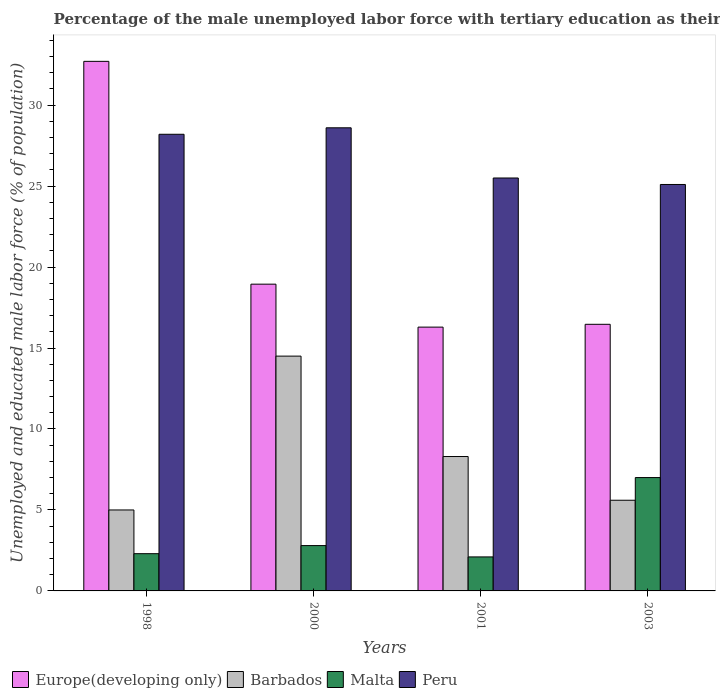Are the number of bars on each tick of the X-axis equal?
Make the answer very short. Yes. How many bars are there on the 2nd tick from the right?
Your response must be concise. 4. Across all years, what is the maximum percentage of the unemployed male labor force with tertiary education in Barbados?
Your answer should be compact. 14.5. In which year was the percentage of the unemployed male labor force with tertiary education in Malta minimum?
Offer a very short reply. 2001. What is the total percentage of the unemployed male labor force with tertiary education in Barbados in the graph?
Give a very brief answer. 33.4. What is the difference between the percentage of the unemployed male labor force with tertiary education in Peru in 2000 and that in 2001?
Keep it short and to the point. 3.1. What is the difference between the percentage of the unemployed male labor force with tertiary education in Malta in 2000 and the percentage of the unemployed male labor force with tertiary education in Europe(developing only) in 2003?
Provide a succinct answer. -13.66. What is the average percentage of the unemployed male labor force with tertiary education in Barbados per year?
Ensure brevity in your answer.  8.35. In the year 1998, what is the difference between the percentage of the unemployed male labor force with tertiary education in Peru and percentage of the unemployed male labor force with tertiary education in Europe(developing only)?
Make the answer very short. -4.5. In how many years, is the percentage of the unemployed male labor force with tertiary education in Europe(developing only) greater than 21 %?
Keep it short and to the point. 1. What is the ratio of the percentage of the unemployed male labor force with tertiary education in Europe(developing only) in 1998 to that in 2000?
Your answer should be very brief. 1.73. What is the difference between the highest and the second highest percentage of the unemployed male labor force with tertiary education in Europe(developing only)?
Make the answer very short. 13.76. What is the difference between the highest and the lowest percentage of the unemployed male labor force with tertiary education in Malta?
Make the answer very short. 4.9. In how many years, is the percentage of the unemployed male labor force with tertiary education in Europe(developing only) greater than the average percentage of the unemployed male labor force with tertiary education in Europe(developing only) taken over all years?
Your response must be concise. 1. Is the sum of the percentage of the unemployed male labor force with tertiary education in Europe(developing only) in 1998 and 2001 greater than the maximum percentage of the unemployed male labor force with tertiary education in Barbados across all years?
Keep it short and to the point. Yes. What does the 2nd bar from the left in 2003 represents?
Provide a succinct answer. Barbados. What does the 2nd bar from the right in 1998 represents?
Make the answer very short. Malta. Are all the bars in the graph horizontal?
Offer a terse response. No. What is the difference between two consecutive major ticks on the Y-axis?
Your response must be concise. 5. Are the values on the major ticks of Y-axis written in scientific E-notation?
Give a very brief answer. No. Does the graph contain any zero values?
Give a very brief answer. No. Does the graph contain grids?
Your response must be concise. No. Where does the legend appear in the graph?
Keep it short and to the point. Bottom left. How many legend labels are there?
Make the answer very short. 4. How are the legend labels stacked?
Offer a terse response. Horizontal. What is the title of the graph?
Keep it short and to the point. Percentage of the male unemployed labor force with tertiary education as their highest grade. What is the label or title of the X-axis?
Offer a terse response. Years. What is the label or title of the Y-axis?
Make the answer very short. Unemployed and educated male labor force (% of population). What is the Unemployed and educated male labor force (% of population) in Europe(developing only) in 1998?
Keep it short and to the point. 32.7. What is the Unemployed and educated male labor force (% of population) of Malta in 1998?
Your answer should be very brief. 2.3. What is the Unemployed and educated male labor force (% of population) of Peru in 1998?
Your response must be concise. 28.2. What is the Unemployed and educated male labor force (% of population) of Europe(developing only) in 2000?
Your answer should be very brief. 18.94. What is the Unemployed and educated male labor force (% of population) of Malta in 2000?
Provide a succinct answer. 2.8. What is the Unemployed and educated male labor force (% of population) of Peru in 2000?
Offer a very short reply. 28.6. What is the Unemployed and educated male labor force (% of population) in Europe(developing only) in 2001?
Ensure brevity in your answer.  16.29. What is the Unemployed and educated male labor force (% of population) in Barbados in 2001?
Make the answer very short. 8.3. What is the Unemployed and educated male labor force (% of population) of Malta in 2001?
Give a very brief answer. 2.1. What is the Unemployed and educated male labor force (% of population) in Europe(developing only) in 2003?
Ensure brevity in your answer.  16.46. What is the Unemployed and educated male labor force (% of population) in Barbados in 2003?
Keep it short and to the point. 5.6. What is the Unemployed and educated male labor force (% of population) of Peru in 2003?
Provide a short and direct response. 25.1. Across all years, what is the maximum Unemployed and educated male labor force (% of population) of Europe(developing only)?
Give a very brief answer. 32.7. Across all years, what is the maximum Unemployed and educated male labor force (% of population) of Peru?
Provide a succinct answer. 28.6. Across all years, what is the minimum Unemployed and educated male labor force (% of population) in Europe(developing only)?
Your answer should be very brief. 16.29. Across all years, what is the minimum Unemployed and educated male labor force (% of population) in Malta?
Give a very brief answer. 2.1. Across all years, what is the minimum Unemployed and educated male labor force (% of population) in Peru?
Provide a succinct answer. 25.1. What is the total Unemployed and educated male labor force (% of population) of Europe(developing only) in the graph?
Your answer should be compact. 84.4. What is the total Unemployed and educated male labor force (% of population) of Barbados in the graph?
Give a very brief answer. 33.4. What is the total Unemployed and educated male labor force (% of population) of Peru in the graph?
Offer a very short reply. 107.4. What is the difference between the Unemployed and educated male labor force (% of population) of Europe(developing only) in 1998 and that in 2000?
Your answer should be compact. 13.76. What is the difference between the Unemployed and educated male labor force (% of population) of Barbados in 1998 and that in 2000?
Give a very brief answer. -9.5. What is the difference between the Unemployed and educated male labor force (% of population) of Europe(developing only) in 1998 and that in 2001?
Offer a terse response. 16.41. What is the difference between the Unemployed and educated male labor force (% of population) in Barbados in 1998 and that in 2001?
Provide a short and direct response. -3.3. What is the difference between the Unemployed and educated male labor force (% of population) of Europe(developing only) in 1998 and that in 2003?
Ensure brevity in your answer.  16.24. What is the difference between the Unemployed and educated male labor force (% of population) of Malta in 1998 and that in 2003?
Provide a short and direct response. -4.7. What is the difference between the Unemployed and educated male labor force (% of population) in Peru in 1998 and that in 2003?
Your response must be concise. 3.1. What is the difference between the Unemployed and educated male labor force (% of population) in Europe(developing only) in 2000 and that in 2001?
Your answer should be very brief. 2.65. What is the difference between the Unemployed and educated male labor force (% of population) in Malta in 2000 and that in 2001?
Your response must be concise. 0.7. What is the difference between the Unemployed and educated male labor force (% of population) of Europe(developing only) in 2000 and that in 2003?
Give a very brief answer. 2.48. What is the difference between the Unemployed and educated male labor force (% of population) of Barbados in 2000 and that in 2003?
Offer a terse response. 8.9. What is the difference between the Unemployed and educated male labor force (% of population) in Malta in 2000 and that in 2003?
Your response must be concise. -4.2. What is the difference between the Unemployed and educated male labor force (% of population) of Europe(developing only) in 2001 and that in 2003?
Provide a short and direct response. -0.17. What is the difference between the Unemployed and educated male labor force (% of population) of Barbados in 2001 and that in 2003?
Provide a short and direct response. 2.7. What is the difference between the Unemployed and educated male labor force (% of population) in Malta in 2001 and that in 2003?
Your answer should be compact. -4.9. What is the difference between the Unemployed and educated male labor force (% of population) in Europe(developing only) in 1998 and the Unemployed and educated male labor force (% of population) in Barbados in 2000?
Provide a short and direct response. 18.2. What is the difference between the Unemployed and educated male labor force (% of population) of Europe(developing only) in 1998 and the Unemployed and educated male labor force (% of population) of Malta in 2000?
Make the answer very short. 29.9. What is the difference between the Unemployed and educated male labor force (% of population) of Europe(developing only) in 1998 and the Unemployed and educated male labor force (% of population) of Peru in 2000?
Make the answer very short. 4.1. What is the difference between the Unemployed and educated male labor force (% of population) of Barbados in 1998 and the Unemployed and educated male labor force (% of population) of Peru in 2000?
Make the answer very short. -23.6. What is the difference between the Unemployed and educated male labor force (% of population) of Malta in 1998 and the Unemployed and educated male labor force (% of population) of Peru in 2000?
Your answer should be very brief. -26.3. What is the difference between the Unemployed and educated male labor force (% of population) of Europe(developing only) in 1998 and the Unemployed and educated male labor force (% of population) of Barbados in 2001?
Your answer should be very brief. 24.4. What is the difference between the Unemployed and educated male labor force (% of population) in Europe(developing only) in 1998 and the Unemployed and educated male labor force (% of population) in Malta in 2001?
Your answer should be very brief. 30.6. What is the difference between the Unemployed and educated male labor force (% of population) of Europe(developing only) in 1998 and the Unemployed and educated male labor force (% of population) of Peru in 2001?
Ensure brevity in your answer.  7.2. What is the difference between the Unemployed and educated male labor force (% of population) of Barbados in 1998 and the Unemployed and educated male labor force (% of population) of Peru in 2001?
Your answer should be compact. -20.5. What is the difference between the Unemployed and educated male labor force (% of population) in Malta in 1998 and the Unemployed and educated male labor force (% of population) in Peru in 2001?
Your response must be concise. -23.2. What is the difference between the Unemployed and educated male labor force (% of population) in Europe(developing only) in 1998 and the Unemployed and educated male labor force (% of population) in Barbados in 2003?
Offer a terse response. 27.1. What is the difference between the Unemployed and educated male labor force (% of population) in Europe(developing only) in 1998 and the Unemployed and educated male labor force (% of population) in Malta in 2003?
Your answer should be very brief. 25.7. What is the difference between the Unemployed and educated male labor force (% of population) in Europe(developing only) in 1998 and the Unemployed and educated male labor force (% of population) in Peru in 2003?
Offer a very short reply. 7.6. What is the difference between the Unemployed and educated male labor force (% of population) in Barbados in 1998 and the Unemployed and educated male labor force (% of population) in Peru in 2003?
Your answer should be compact. -20.1. What is the difference between the Unemployed and educated male labor force (% of population) in Malta in 1998 and the Unemployed and educated male labor force (% of population) in Peru in 2003?
Keep it short and to the point. -22.8. What is the difference between the Unemployed and educated male labor force (% of population) in Europe(developing only) in 2000 and the Unemployed and educated male labor force (% of population) in Barbados in 2001?
Provide a short and direct response. 10.64. What is the difference between the Unemployed and educated male labor force (% of population) in Europe(developing only) in 2000 and the Unemployed and educated male labor force (% of population) in Malta in 2001?
Offer a very short reply. 16.84. What is the difference between the Unemployed and educated male labor force (% of population) in Europe(developing only) in 2000 and the Unemployed and educated male labor force (% of population) in Peru in 2001?
Your answer should be very brief. -6.56. What is the difference between the Unemployed and educated male labor force (% of population) in Barbados in 2000 and the Unemployed and educated male labor force (% of population) in Malta in 2001?
Your answer should be very brief. 12.4. What is the difference between the Unemployed and educated male labor force (% of population) of Barbados in 2000 and the Unemployed and educated male labor force (% of population) of Peru in 2001?
Keep it short and to the point. -11. What is the difference between the Unemployed and educated male labor force (% of population) of Malta in 2000 and the Unemployed and educated male labor force (% of population) of Peru in 2001?
Make the answer very short. -22.7. What is the difference between the Unemployed and educated male labor force (% of population) in Europe(developing only) in 2000 and the Unemployed and educated male labor force (% of population) in Barbados in 2003?
Give a very brief answer. 13.34. What is the difference between the Unemployed and educated male labor force (% of population) of Europe(developing only) in 2000 and the Unemployed and educated male labor force (% of population) of Malta in 2003?
Offer a very short reply. 11.94. What is the difference between the Unemployed and educated male labor force (% of population) of Europe(developing only) in 2000 and the Unemployed and educated male labor force (% of population) of Peru in 2003?
Your answer should be compact. -6.16. What is the difference between the Unemployed and educated male labor force (% of population) in Malta in 2000 and the Unemployed and educated male labor force (% of population) in Peru in 2003?
Offer a very short reply. -22.3. What is the difference between the Unemployed and educated male labor force (% of population) in Europe(developing only) in 2001 and the Unemployed and educated male labor force (% of population) in Barbados in 2003?
Ensure brevity in your answer.  10.69. What is the difference between the Unemployed and educated male labor force (% of population) of Europe(developing only) in 2001 and the Unemployed and educated male labor force (% of population) of Malta in 2003?
Offer a terse response. 9.29. What is the difference between the Unemployed and educated male labor force (% of population) of Europe(developing only) in 2001 and the Unemployed and educated male labor force (% of population) of Peru in 2003?
Provide a succinct answer. -8.81. What is the difference between the Unemployed and educated male labor force (% of population) of Barbados in 2001 and the Unemployed and educated male labor force (% of population) of Peru in 2003?
Your answer should be very brief. -16.8. What is the average Unemployed and educated male labor force (% of population) of Europe(developing only) per year?
Keep it short and to the point. 21.1. What is the average Unemployed and educated male labor force (% of population) in Barbados per year?
Make the answer very short. 8.35. What is the average Unemployed and educated male labor force (% of population) in Malta per year?
Your response must be concise. 3.55. What is the average Unemployed and educated male labor force (% of population) of Peru per year?
Make the answer very short. 26.85. In the year 1998, what is the difference between the Unemployed and educated male labor force (% of population) in Europe(developing only) and Unemployed and educated male labor force (% of population) in Barbados?
Ensure brevity in your answer.  27.7. In the year 1998, what is the difference between the Unemployed and educated male labor force (% of population) of Europe(developing only) and Unemployed and educated male labor force (% of population) of Malta?
Your answer should be very brief. 30.4. In the year 1998, what is the difference between the Unemployed and educated male labor force (% of population) of Europe(developing only) and Unemployed and educated male labor force (% of population) of Peru?
Ensure brevity in your answer.  4.5. In the year 1998, what is the difference between the Unemployed and educated male labor force (% of population) in Barbados and Unemployed and educated male labor force (% of population) in Peru?
Provide a short and direct response. -23.2. In the year 1998, what is the difference between the Unemployed and educated male labor force (% of population) of Malta and Unemployed and educated male labor force (% of population) of Peru?
Keep it short and to the point. -25.9. In the year 2000, what is the difference between the Unemployed and educated male labor force (% of population) in Europe(developing only) and Unemployed and educated male labor force (% of population) in Barbados?
Ensure brevity in your answer.  4.44. In the year 2000, what is the difference between the Unemployed and educated male labor force (% of population) of Europe(developing only) and Unemployed and educated male labor force (% of population) of Malta?
Your answer should be very brief. 16.14. In the year 2000, what is the difference between the Unemployed and educated male labor force (% of population) in Europe(developing only) and Unemployed and educated male labor force (% of population) in Peru?
Keep it short and to the point. -9.66. In the year 2000, what is the difference between the Unemployed and educated male labor force (% of population) of Barbados and Unemployed and educated male labor force (% of population) of Peru?
Your response must be concise. -14.1. In the year 2000, what is the difference between the Unemployed and educated male labor force (% of population) in Malta and Unemployed and educated male labor force (% of population) in Peru?
Offer a very short reply. -25.8. In the year 2001, what is the difference between the Unemployed and educated male labor force (% of population) in Europe(developing only) and Unemployed and educated male labor force (% of population) in Barbados?
Make the answer very short. 7.99. In the year 2001, what is the difference between the Unemployed and educated male labor force (% of population) in Europe(developing only) and Unemployed and educated male labor force (% of population) in Malta?
Your answer should be compact. 14.19. In the year 2001, what is the difference between the Unemployed and educated male labor force (% of population) of Europe(developing only) and Unemployed and educated male labor force (% of population) of Peru?
Provide a succinct answer. -9.21. In the year 2001, what is the difference between the Unemployed and educated male labor force (% of population) in Barbados and Unemployed and educated male labor force (% of population) in Peru?
Offer a terse response. -17.2. In the year 2001, what is the difference between the Unemployed and educated male labor force (% of population) in Malta and Unemployed and educated male labor force (% of population) in Peru?
Give a very brief answer. -23.4. In the year 2003, what is the difference between the Unemployed and educated male labor force (% of population) of Europe(developing only) and Unemployed and educated male labor force (% of population) of Barbados?
Your answer should be very brief. 10.86. In the year 2003, what is the difference between the Unemployed and educated male labor force (% of population) in Europe(developing only) and Unemployed and educated male labor force (% of population) in Malta?
Offer a terse response. 9.46. In the year 2003, what is the difference between the Unemployed and educated male labor force (% of population) in Europe(developing only) and Unemployed and educated male labor force (% of population) in Peru?
Your answer should be compact. -8.64. In the year 2003, what is the difference between the Unemployed and educated male labor force (% of population) of Barbados and Unemployed and educated male labor force (% of population) of Malta?
Your answer should be very brief. -1.4. In the year 2003, what is the difference between the Unemployed and educated male labor force (% of population) of Barbados and Unemployed and educated male labor force (% of population) of Peru?
Keep it short and to the point. -19.5. In the year 2003, what is the difference between the Unemployed and educated male labor force (% of population) in Malta and Unemployed and educated male labor force (% of population) in Peru?
Ensure brevity in your answer.  -18.1. What is the ratio of the Unemployed and educated male labor force (% of population) of Europe(developing only) in 1998 to that in 2000?
Ensure brevity in your answer.  1.73. What is the ratio of the Unemployed and educated male labor force (% of population) in Barbados in 1998 to that in 2000?
Give a very brief answer. 0.34. What is the ratio of the Unemployed and educated male labor force (% of population) in Malta in 1998 to that in 2000?
Keep it short and to the point. 0.82. What is the ratio of the Unemployed and educated male labor force (% of population) of Peru in 1998 to that in 2000?
Give a very brief answer. 0.99. What is the ratio of the Unemployed and educated male labor force (% of population) in Europe(developing only) in 1998 to that in 2001?
Give a very brief answer. 2.01. What is the ratio of the Unemployed and educated male labor force (% of population) of Barbados in 1998 to that in 2001?
Offer a very short reply. 0.6. What is the ratio of the Unemployed and educated male labor force (% of population) of Malta in 1998 to that in 2001?
Your answer should be very brief. 1.1. What is the ratio of the Unemployed and educated male labor force (% of population) of Peru in 1998 to that in 2001?
Provide a short and direct response. 1.11. What is the ratio of the Unemployed and educated male labor force (% of population) of Europe(developing only) in 1998 to that in 2003?
Give a very brief answer. 1.99. What is the ratio of the Unemployed and educated male labor force (% of population) of Barbados in 1998 to that in 2003?
Give a very brief answer. 0.89. What is the ratio of the Unemployed and educated male labor force (% of population) of Malta in 1998 to that in 2003?
Give a very brief answer. 0.33. What is the ratio of the Unemployed and educated male labor force (% of population) in Peru in 1998 to that in 2003?
Make the answer very short. 1.12. What is the ratio of the Unemployed and educated male labor force (% of population) of Europe(developing only) in 2000 to that in 2001?
Provide a succinct answer. 1.16. What is the ratio of the Unemployed and educated male labor force (% of population) in Barbados in 2000 to that in 2001?
Your response must be concise. 1.75. What is the ratio of the Unemployed and educated male labor force (% of population) in Malta in 2000 to that in 2001?
Give a very brief answer. 1.33. What is the ratio of the Unemployed and educated male labor force (% of population) in Peru in 2000 to that in 2001?
Keep it short and to the point. 1.12. What is the ratio of the Unemployed and educated male labor force (% of population) in Europe(developing only) in 2000 to that in 2003?
Provide a succinct answer. 1.15. What is the ratio of the Unemployed and educated male labor force (% of population) in Barbados in 2000 to that in 2003?
Give a very brief answer. 2.59. What is the ratio of the Unemployed and educated male labor force (% of population) in Malta in 2000 to that in 2003?
Keep it short and to the point. 0.4. What is the ratio of the Unemployed and educated male labor force (% of population) in Peru in 2000 to that in 2003?
Offer a terse response. 1.14. What is the ratio of the Unemployed and educated male labor force (% of population) in Europe(developing only) in 2001 to that in 2003?
Ensure brevity in your answer.  0.99. What is the ratio of the Unemployed and educated male labor force (% of population) in Barbados in 2001 to that in 2003?
Make the answer very short. 1.48. What is the ratio of the Unemployed and educated male labor force (% of population) of Malta in 2001 to that in 2003?
Give a very brief answer. 0.3. What is the ratio of the Unemployed and educated male labor force (% of population) in Peru in 2001 to that in 2003?
Ensure brevity in your answer.  1.02. What is the difference between the highest and the second highest Unemployed and educated male labor force (% of population) in Europe(developing only)?
Keep it short and to the point. 13.76. What is the difference between the highest and the second highest Unemployed and educated male labor force (% of population) of Barbados?
Keep it short and to the point. 6.2. What is the difference between the highest and the second highest Unemployed and educated male labor force (% of population) of Malta?
Offer a very short reply. 4.2. What is the difference between the highest and the lowest Unemployed and educated male labor force (% of population) of Europe(developing only)?
Provide a short and direct response. 16.41. What is the difference between the highest and the lowest Unemployed and educated male labor force (% of population) of Malta?
Provide a succinct answer. 4.9. 